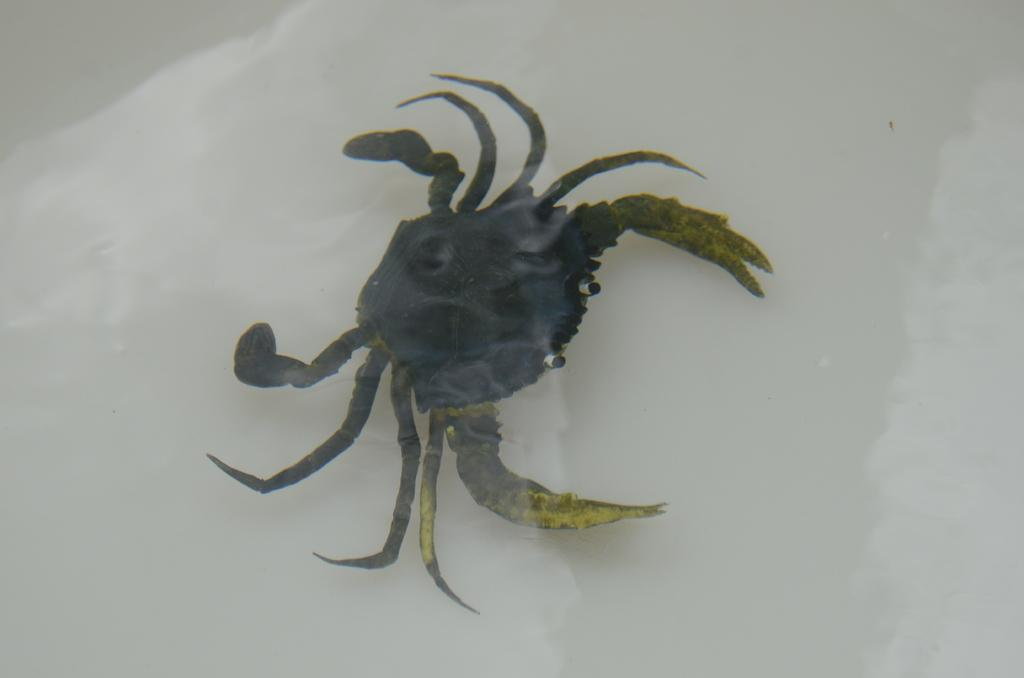What type of animal is in the image? There is a crab in the image. Where is the crab located? The crab is in the water. How does the crab form a sentence in the image? Crabs do not have the ability to form sentences, as they are animals without the capacity for language. 